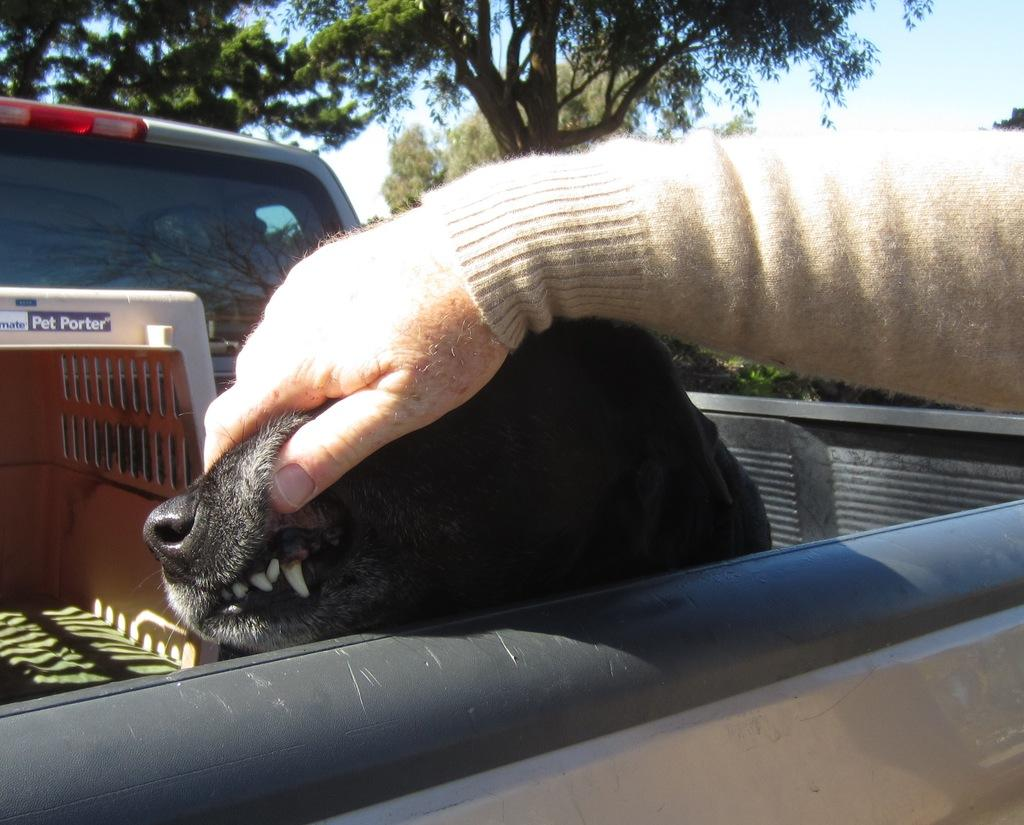What is the main subject of the image? There is a person in the image. What is the person doing in the image? The person is holding a dog. Can you describe the dog in the image? There is a dog in the image. What else can be seen in the image besides the person and the dog? There are objects in a vehicle and trees visible in the background. What is visible at the top of the image? The sky is visible at the top of the image. Where is the zipper located on the dog in the image? There is no zipper present on the dog in the image. What type of map can be seen on the person's hand in the image? There is no map present in the image; the person is holding a dog. 